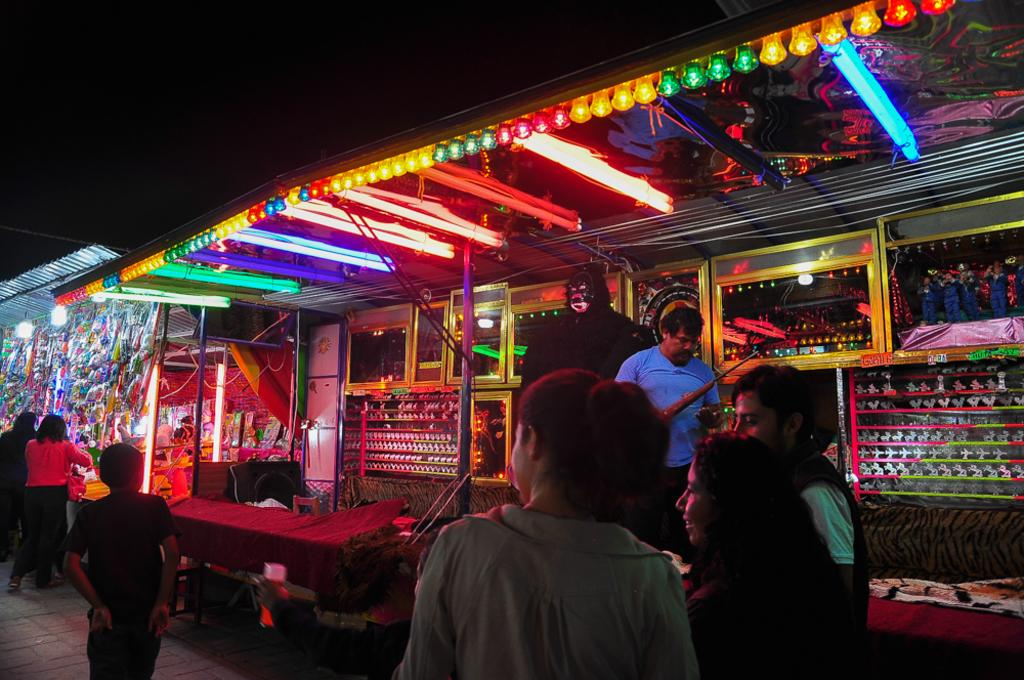What are the people in the image doing? The people in the image are standing on a path. What can be seen in the background or surroundings of the people? There are lights visible in the image. What is inside the shop in the image? There are toys in a shop in the image. Can you describe any other objects or features in the image? There are other objects present in the image. What is the profit made by the grandmother in the image? There is no mention of a grandmother or profit in the image. 